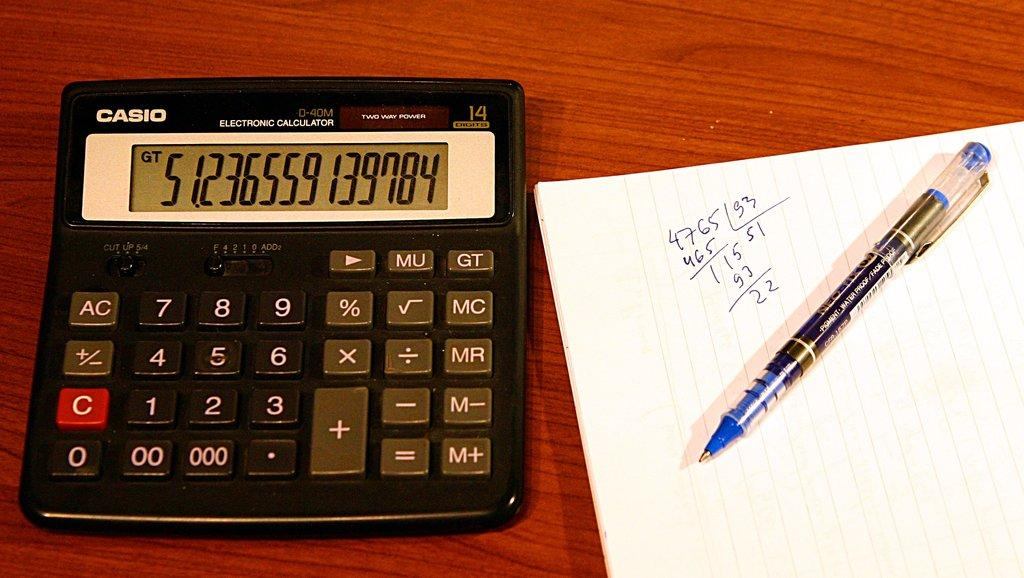<image>
Provide a brief description of the given image. A Casio calculator next to a notepad and pen. 